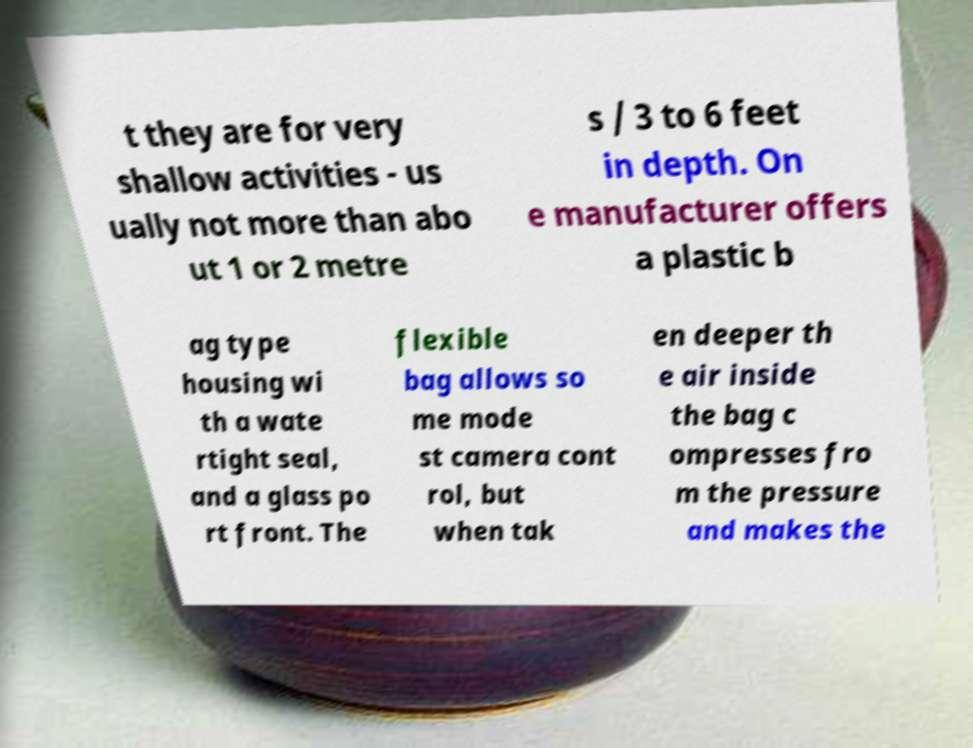Please read and relay the text visible in this image. What does it say? t they are for very shallow activities - us ually not more than abo ut 1 or 2 metre s / 3 to 6 feet in depth. On e manufacturer offers a plastic b ag type housing wi th a wate rtight seal, and a glass po rt front. The flexible bag allows so me mode st camera cont rol, but when tak en deeper th e air inside the bag c ompresses fro m the pressure and makes the 